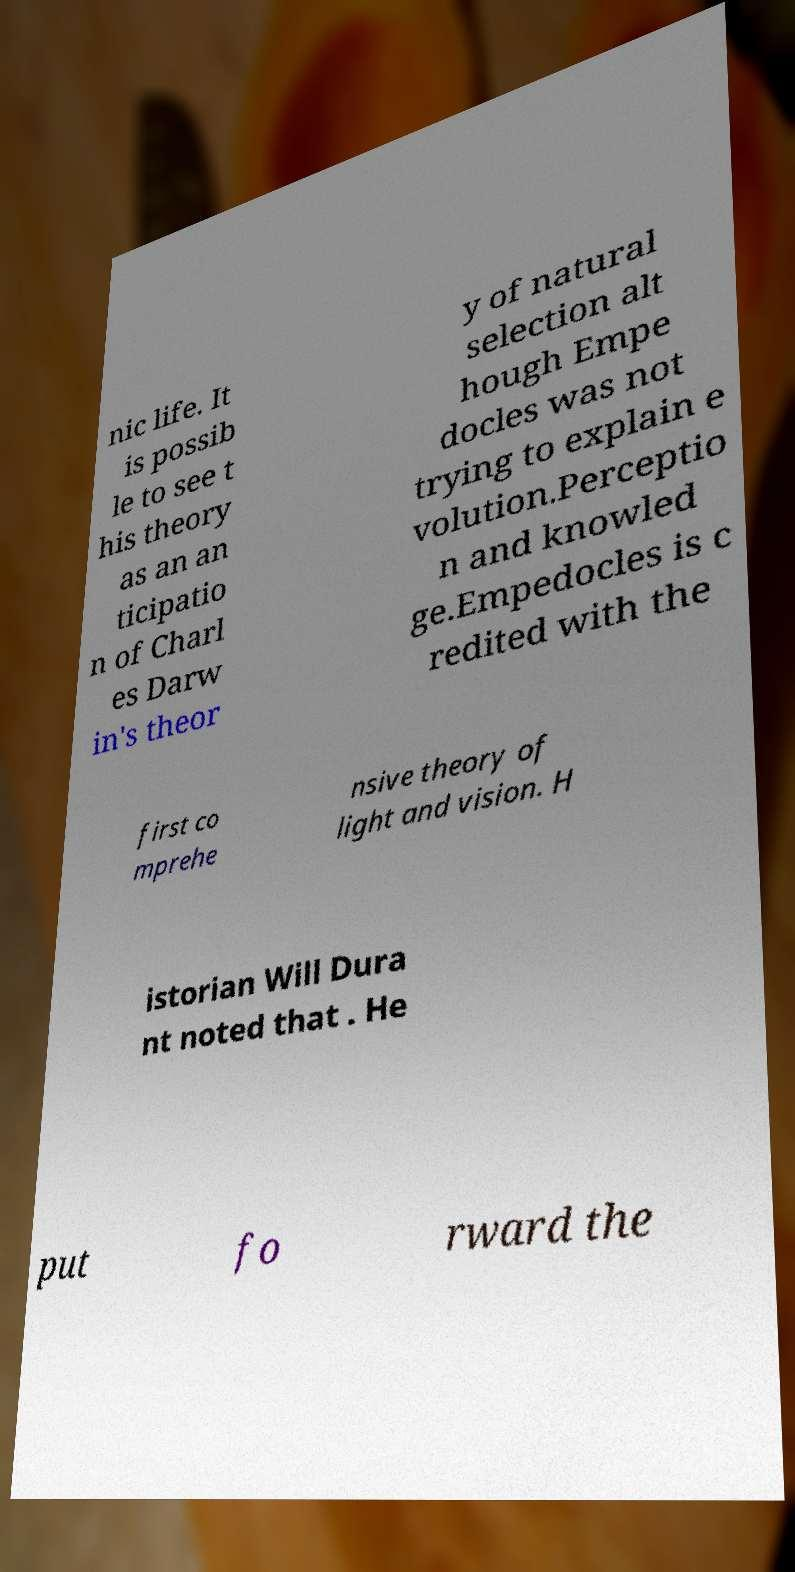Can you read and provide the text displayed in the image?This photo seems to have some interesting text. Can you extract and type it out for me? nic life. It is possib le to see t his theory as an an ticipatio n of Charl es Darw in's theor y of natural selection alt hough Empe docles was not trying to explain e volution.Perceptio n and knowled ge.Empedocles is c redited with the first co mprehe nsive theory of light and vision. H istorian Will Dura nt noted that . He put fo rward the 